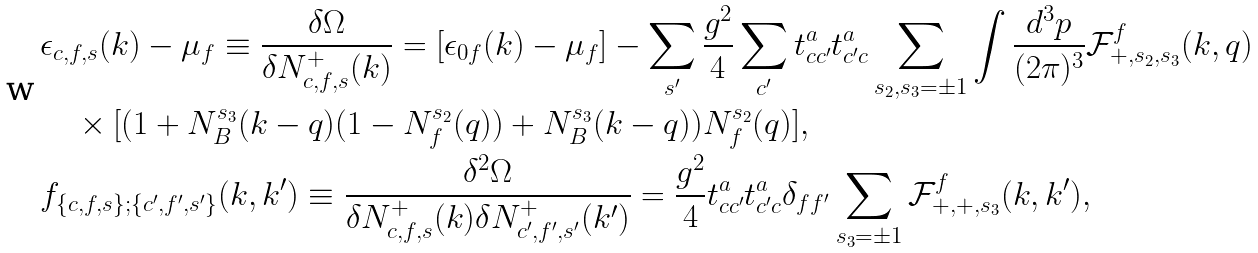<formula> <loc_0><loc_0><loc_500><loc_500>& \epsilon _ { c , f , s } ( k ) - \mu _ { f } \equiv \frac { \delta \Omega } { \delta N _ { c , f , s } ^ { + } ( k ) } = [ \epsilon _ { 0 f } ( k ) - \mu _ { f } ] - \sum _ { s ^ { \prime } } \frac { g ^ { 2 } } { 4 } \sum _ { c ^ { \prime } } t _ { c c ^ { \prime } } ^ { a } t _ { c ^ { \prime } c } ^ { a } \sum _ { s _ { 2 } , s _ { 3 } = \pm 1 } \int \frac { d ^ { 3 } p } { ( 2 \pi ) ^ { 3 } } \mathcal { F } ^ { f } _ { + , s _ { 2 } , s _ { 3 } } ( k , q ) \\ & \quad \times [ ( 1 + N _ { B } ^ { s _ { 3 } } ( k - q ) ( 1 - N _ { f } ^ { s _ { 2 } } ( q ) ) + N _ { B } ^ { s _ { 3 } } ( k - q ) ) N _ { f } ^ { s _ { 2 } } ( q ) ] , \\ & f _ { \{ c , f , s \} ; \{ c ^ { \prime } , f ^ { \prime } , s ^ { \prime } \} } ( k , k ^ { \prime } ) \equiv \frac { \delta ^ { 2 } \Omega } { \delta N _ { c , f , s } ^ { + } ( k ) \delta N _ { c ^ { \prime } , f ^ { \prime } , s ^ { \prime } } ^ { + } ( k ^ { \prime } ) } = \frac { g ^ { 2 } } { 4 } t _ { c c ^ { \prime } } ^ { a } t _ { c ^ { \prime } c } ^ { a } \delta _ { f f ^ { \prime } } \sum _ { s _ { 3 } = \pm 1 } \mathcal { F } ^ { f } _ { + , + , s _ { 3 } } ( k , k ^ { \prime } ) ,</formula> 